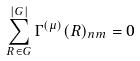<formula> <loc_0><loc_0><loc_500><loc_500>\sum _ { R \in G } ^ { | G | } \Gamma ^ { ( \mu ) } ( R ) _ { n m } = 0</formula> 